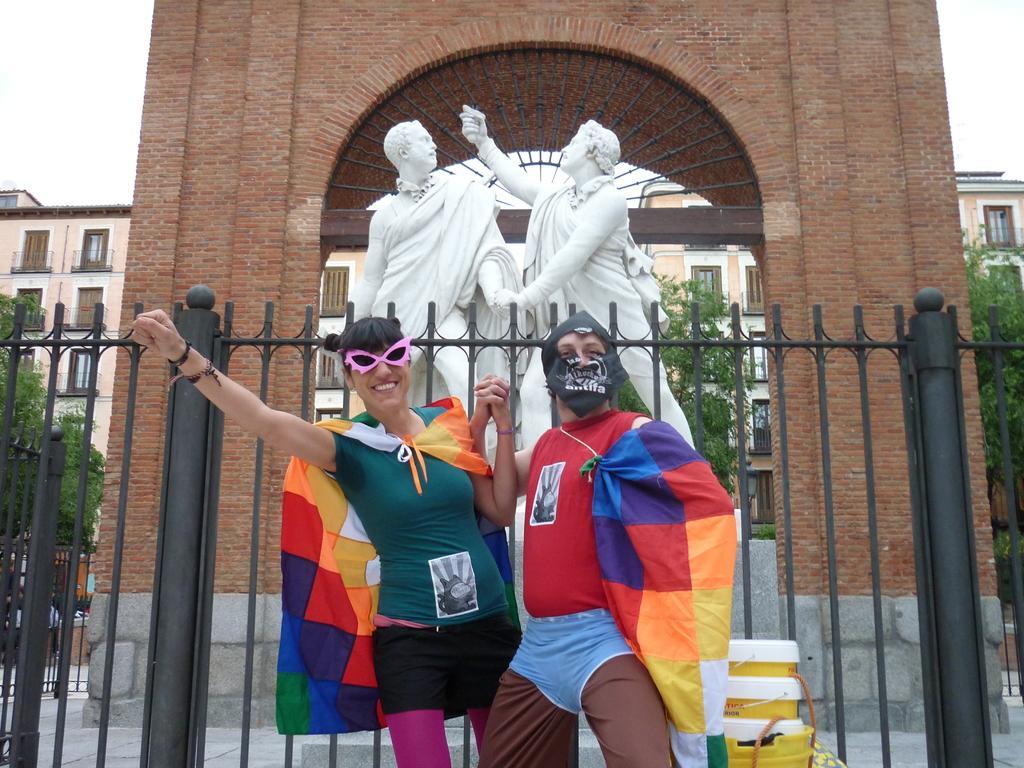In one or two sentences, can you explain what this image depicts? In this image, there are two persons standing with fancy dresses. Behind the two persons, I can see the sculptures, iron grilles and an arch on the wall. At the bottom of the image, I can see few objects. In the background, there are trees, buildings and I can see the sky. 